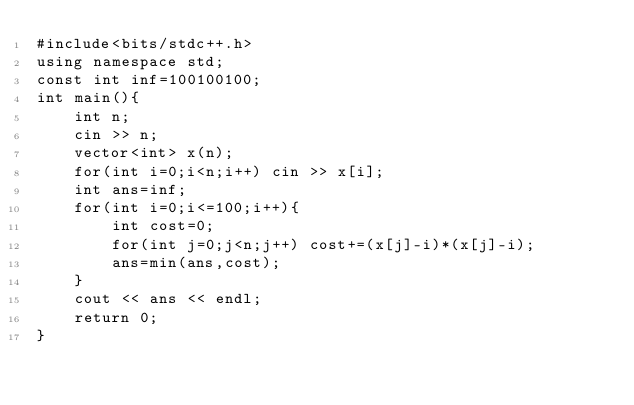Convert code to text. <code><loc_0><loc_0><loc_500><loc_500><_C++_>#include<bits/stdc++.h>
using namespace std;
const int inf=100100100;
int main(){
    int n;
    cin >> n;
    vector<int> x(n);
    for(int i=0;i<n;i++) cin >> x[i];
    int ans=inf;
    for(int i=0;i<=100;i++){
        int cost=0;
        for(int j=0;j<n;j++) cost+=(x[j]-i)*(x[j]-i);
        ans=min(ans,cost);
    }
    cout << ans << endl;
    return 0;
}</code> 